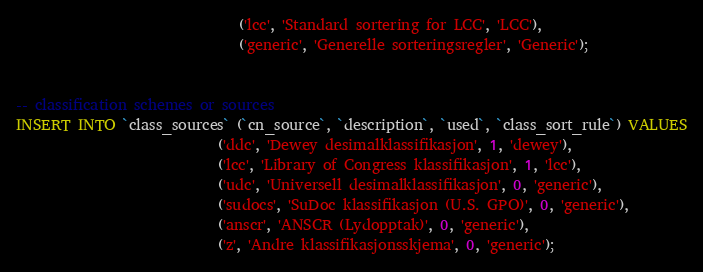Convert code to text. <code><loc_0><loc_0><loc_500><loc_500><_SQL_>                               ('lcc', 'Standard sortering for LCC', 'LCC'),
                               ('generic', 'Generelle sorteringsregler', 'Generic');


-- classification schemes or sources
INSERT INTO `class_sources` (`cn_source`, `description`, `used`, `class_sort_rule`) VALUES
                            ('ddc', 'Dewey desimalklassifikasjon', 1, 'dewey'),
                            ('lcc', 'Library of Congress klassifikasjon', 1, 'lcc'),
                            ('udc', 'Universell desimalklassifikasjon', 0, 'generic'),
                            ('sudocs', 'SuDoc klassifikasjon (U.S. GPO)', 0, 'generic'),
                            ('anscr', 'ANSCR (Lydopptak)', 0, 'generic'),
                            ('z', 'Andre klassifikasjonsskjema', 0, 'generic');
</code> 